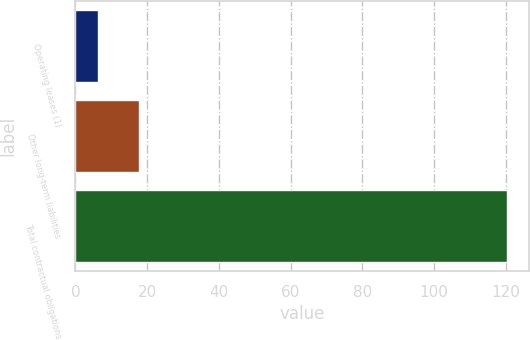Convert chart. <chart><loc_0><loc_0><loc_500><loc_500><bar_chart><fcel>Operating leases (1)<fcel>Other long-term liabilities<fcel>Total contractual obligations<nl><fcel>6.3<fcel>17.71<fcel>120.4<nl></chart> 